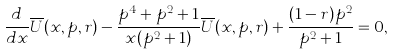Convert formula to latex. <formula><loc_0><loc_0><loc_500><loc_500>\frac { d } { d x } \overline { U } ( x , p , r ) - \frac { p ^ { 4 } + p ^ { 2 } + 1 } { x ( p ^ { 2 } + 1 ) } \overline { U } ( x , p , r ) + \frac { ( 1 - r ) p ^ { 2 } } { p ^ { 2 } + 1 } = 0 ,</formula> 